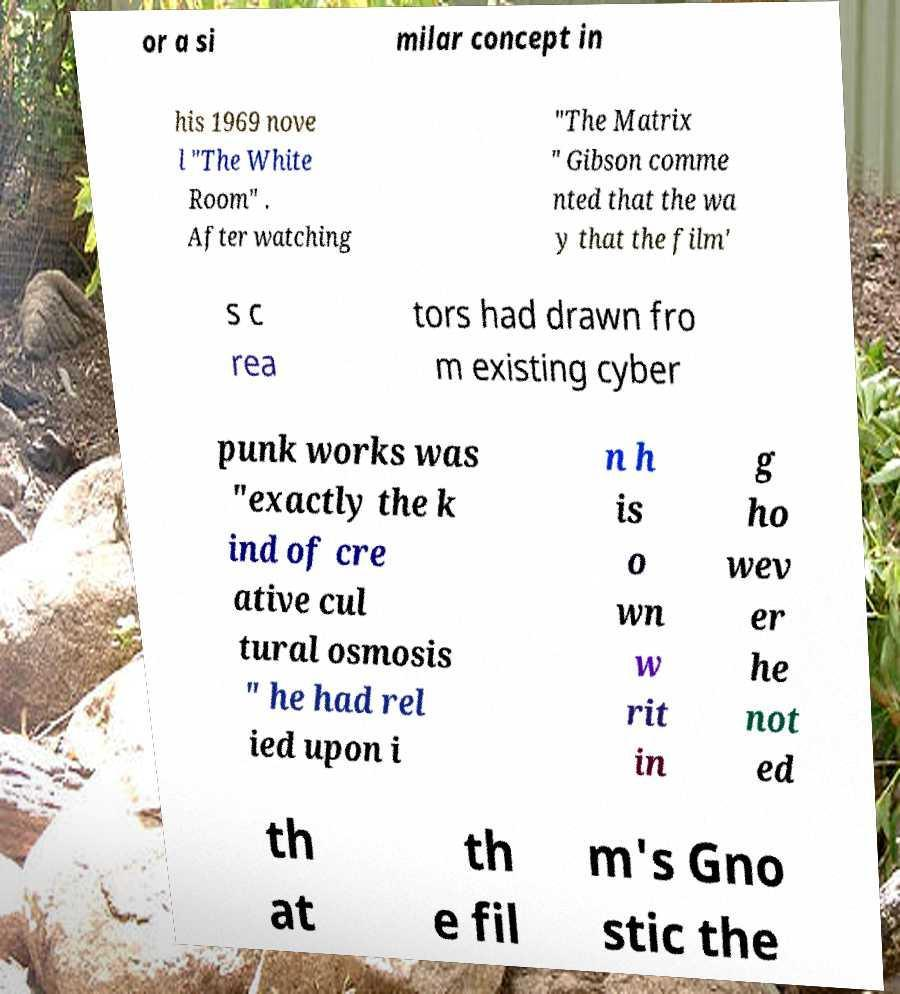I need the written content from this picture converted into text. Can you do that? or a si milar concept in his 1969 nove l "The White Room" . After watching "The Matrix " Gibson comme nted that the wa y that the film' s c rea tors had drawn fro m existing cyber punk works was "exactly the k ind of cre ative cul tural osmosis " he had rel ied upon i n h is o wn w rit in g ho wev er he not ed th at th e fil m's Gno stic the 